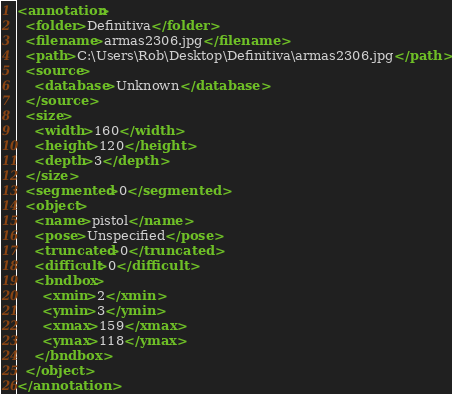Convert code to text. <code><loc_0><loc_0><loc_500><loc_500><_XML_><annotation>
  <folder>Definitiva</folder>
  <filename>armas2306.jpg</filename>
  <path>C:\Users\Rob\Desktop\Definitiva\armas2306.jpg</path>
  <source>
    <database>Unknown</database>
  </source>
  <size>
    <width>160</width>
    <height>120</height>
    <depth>3</depth>
  </size>
  <segmented>0</segmented>
  <object>
    <name>pistol</name>
    <pose>Unspecified</pose>
    <truncated>0</truncated>
    <difficult>0</difficult>
    <bndbox>
      <xmin>2</xmin>
      <ymin>3</ymin>
      <xmax>159</xmax>
      <ymax>118</ymax>
    </bndbox>
  </object>
</annotation>
</code> 